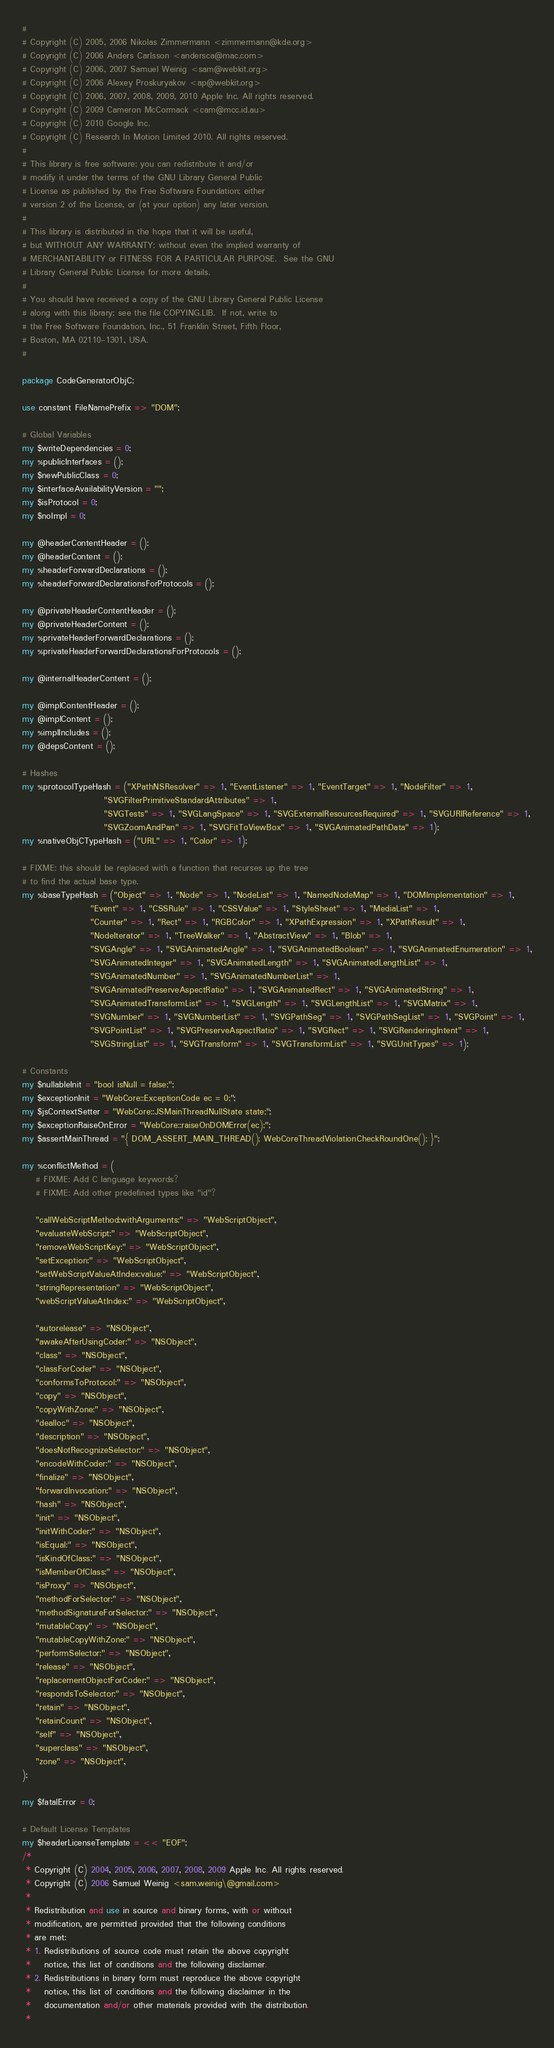Convert code to text. <code><loc_0><loc_0><loc_500><loc_500><_Perl_># 
# Copyright (C) 2005, 2006 Nikolas Zimmermann <zimmermann@kde.org>
# Copyright (C) 2006 Anders Carlsson <andersca@mac.com> 
# Copyright (C) 2006, 2007 Samuel Weinig <sam@webkit.org>
# Copyright (C) 2006 Alexey Proskuryakov <ap@webkit.org>
# Copyright (C) 2006, 2007, 2008, 2009, 2010 Apple Inc. All rights reserved.
# Copyright (C) 2009 Cameron McCormack <cam@mcc.id.au>
# Copyright (C) 2010 Google Inc.
# Copyright (C) Research In Motion Limited 2010. All rights reserved.
#
# This library is free software; you can redistribute it and/or
# modify it under the terms of the GNU Library General Public
# License as published by the Free Software Foundation; either
# version 2 of the License, or (at your option) any later version.
# 
# This library is distributed in the hope that it will be useful,
# but WITHOUT ANY WARRANTY; without even the implied warranty of
# MERCHANTABILITY or FITNESS FOR A PARTICULAR PURPOSE.  See the GNU
# Library General Public License for more details.
# 
# You should have received a copy of the GNU Library General Public License
# along with this library; see the file COPYING.LIB.  If not, write to
# the Free Software Foundation, Inc., 51 Franklin Street, Fifth Floor,
# Boston, MA 02110-1301, USA.
#

package CodeGeneratorObjC;

use constant FileNamePrefix => "DOM";

# Global Variables
my $writeDependencies = 0;
my %publicInterfaces = ();
my $newPublicClass = 0;
my $interfaceAvailabilityVersion = "";
my $isProtocol = 0;
my $noImpl = 0;

my @headerContentHeader = ();
my @headerContent = ();
my %headerForwardDeclarations = ();
my %headerForwardDeclarationsForProtocols = ();

my @privateHeaderContentHeader = ();
my @privateHeaderContent = ();
my %privateHeaderForwardDeclarations = ();
my %privateHeaderForwardDeclarationsForProtocols = ();

my @internalHeaderContent = ();

my @implContentHeader = ();
my @implContent = ();
my %implIncludes = ();
my @depsContent = ();

# Hashes
my %protocolTypeHash = ("XPathNSResolver" => 1, "EventListener" => 1, "EventTarget" => 1, "NodeFilter" => 1,
                        "SVGFilterPrimitiveStandardAttributes" => 1, 
                        "SVGTests" => 1, "SVGLangSpace" => 1, "SVGExternalResourcesRequired" => 1, "SVGURIReference" => 1,
                        "SVGZoomAndPan" => 1, "SVGFitToViewBox" => 1, "SVGAnimatedPathData" => 1);
my %nativeObjCTypeHash = ("URL" => 1, "Color" => 1);

# FIXME: this should be replaced with a function that recurses up the tree
# to find the actual base type.
my %baseTypeHash = ("Object" => 1, "Node" => 1, "NodeList" => 1, "NamedNodeMap" => 1, "DOMImplementation" => 1,
                    "Event" => 1, "CSSRule" => 1, "CSSValue" => 1, "StyleSheet" => 1, "MediaList" => 1,
                    "Counter" => 1, "Rect" => 1, "RGBColor" => 1, "XPathExpression" => 1, "XPathResult" => 1,
                    "NodeIterator" => 1, "TreeWalker" => 1, "AbstractView" => 1, "Blob" => 1,
                    "SVGAngle" => 1, "SVGAnimatedAngle" => 1, "SVGAnimatedBoolean" => 1, "SVGAnimatedEnumeration" => 1,
                    "SVGAnimatedInteger" => 1, "SVGAnimatedLength" => 1, "SVGAnimatedLengthList" => 1,
                    "SVGAnimatedNumber" => 1, "SVGAnimatedNumberList" => 1,
                    "SVGAnimatedPreserveAspectRatio" => 1, "SVGAnimatedRect" => 1, "SVGAnimatedString" => 1,
                    "SVGAnimatedTransformList" => 1, "SVGLength" => 1, "SVGLengthList" => 1, "SVGMatrix" => 1,
                    "SVGNumber" => 1, "SVGNumberList" => 1, "SVGPathSeg" => 1, "SVGPathSegList" => 1, "SVGPoint" => 1,
                    "SVGPointList" => 1, "SVGPreserveAspectRatio" => 1, "SVGRect" => 1, "SVGRenderingIntent" => 1,
                    "SVGStringList" => 1, "SVGTransform" => 1, "SVGTransformList" => 1, "SVGUnitTypes" => 1);

# Constants
my $nullableInit = "bool isNull = false;";
my $exceptionInit = "WebCore::ExceptionCode ec = 0;";
my $jsContextSetter = "WebCore::JSMainThreadNullState state;";
my $exceptionRaiseOnError = "WebCore::raiseOnDOMError(ec);";
my $assertMainThread = "{ DOM_ASSERT_MAIN_THREAD(); WebCoreThreadViolationCheckRoundOne(); }";

my %conflictMethod = (
    # FIXME: Add C language keywords?
    # FIXME: Add other predefined types like "id"?

    "callWebScriptMethod:withArguments:" => "WebScriptObject",
    "evaluateWebScript:" => "WebScriptObject",
    "removeWebScriptKey:" => "WebScriptObject",
    "setException:" => "WebScriptObject",
    "setWebScriptValueAtIndex:value:" => "WebScriptObject",
    "stringRepresentation" => "WebScriptObject",
    "webScriptValueAtIndex:" => "WebScriptObject",

    "autorelease" => "NSObject",
    "awakeAfterUsingCoder:" => "NSObject",
    "class" => "NSObject",
    "classForCoder" => "NSObject",
    "conformsToProtocol:" => "NSObject",
    "copy" => "NSObject",
    "copyWithZone:" => "NSObject",
    "dealloc" => "NSObject",
    "description" => "NSObject",
    "doesNotRecognizeSelector:" => "NSObject",
    "encodeWithCoder:" => "NSObject",
    "finalize" => "NSObject",
    "forwardInvocation:" => "NSObject",
    "hash" => "NSObject",
    "init" => "NSObject",
    "initWithCoder:" => "NSObject",
    "isEqual:" => "NSObject",
    "isKindOfClass:" => "NSObject",
    "isMemberOfClass:" => "NSObject",
    "isProxy" => "NSObject",
    "methodForSelector:" => "NSObject",
    "methodSignatureForSelector:" => "NSObject",
    "mutableCopy" => "NSObject",
    "mutableCopyWithZone:" => "NSObject",
    "performSelector:" => "NSObject",
    "release" => "NSObject",
    "replacementObjectForCoder:" => "NSObject",
    "respondsToSelector:" => "NSObject",
    "retain" => "NSObject",
    "retainCount" => "NSObject",
    "self" => "NSObject",
    "superclass" => "NSObject",
    "zone" => "NSObject",
);

my $fatalError = 0;

# Default License Templates
my $headerLicenseTemplate = << "EOF";
/*
 * Copyright (C) 2004, 2005, 2006, 2007, 2008, 2009 Apple Inc. All rights reserved.
 * Copyright (C) 2006 Samuel Weinig <sam.weinig\@gmail.com>
 *
 * Redistribution and use in source and binary forms, with or without
 * modification, are permitted provided that the following conditions
 * are met:
 * 1. Redistributions of source code must retain the above copyright
 *    notice, this list of conditions and the following disclaimer.
 * 2. Redistributions in binary form must reproduce the above copyright
 *    notice, this list of conditions and the following disclaimer in the
 *    documentation and/or other materials provided with the distribution.
 *</code> 